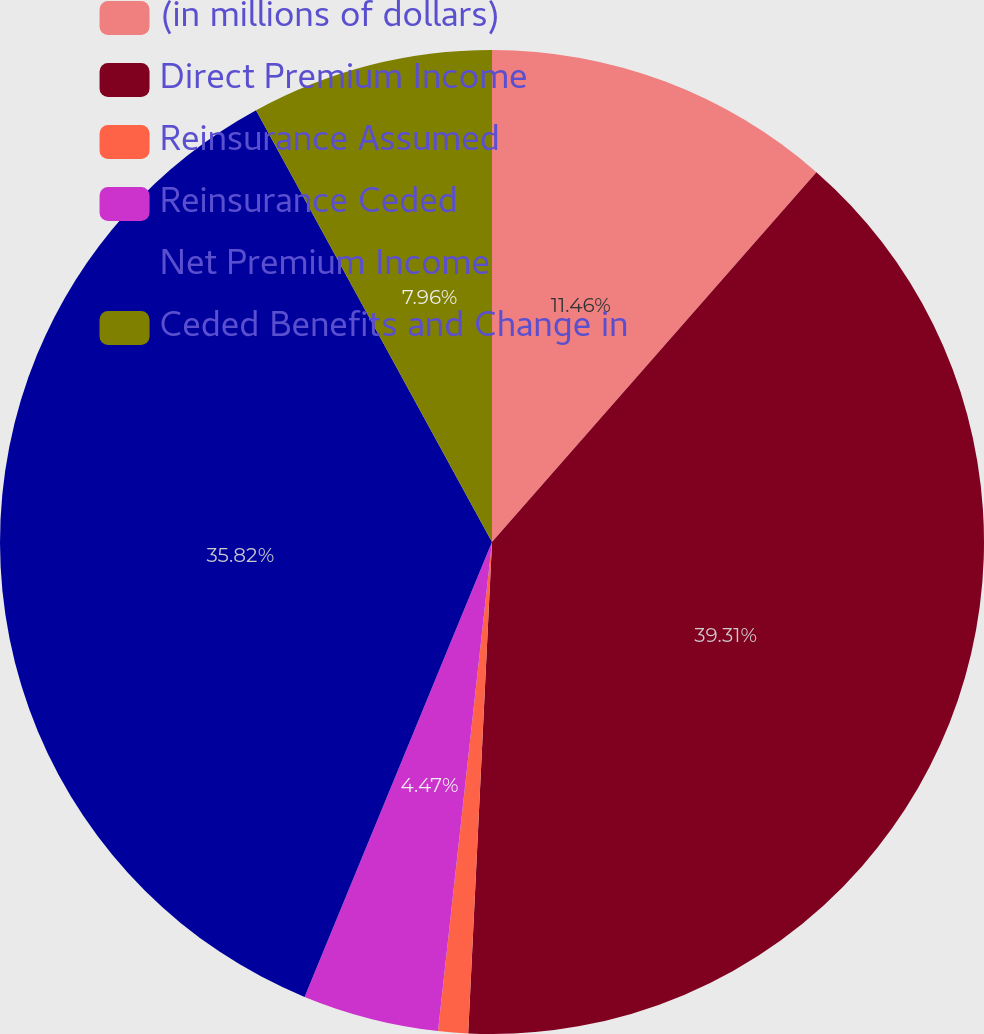Convert chart. <chart><loc_0><loc_0><loc_500><loc_500><pie_chart><fcel>(in millions of dollars)<fcel>Direct Premium Income<fcel>Reinsurance Assumed<fcel>Reinsurance Ceded<fcel>Net Premium Income<fcel>Ceded Benefits and Change in<nl><fcel>11.46%<fcel>39.31%<fcel>0.98%<fcel>4.47%<fcel>35.82%<fcel>7.96%<nl></chart> 